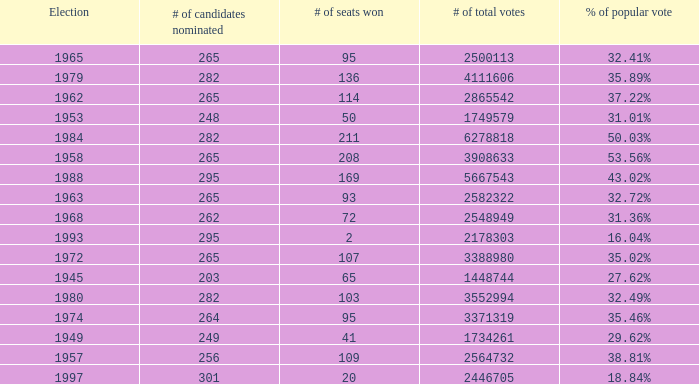What is the # of seats one for the election in 1974? 95.0. 